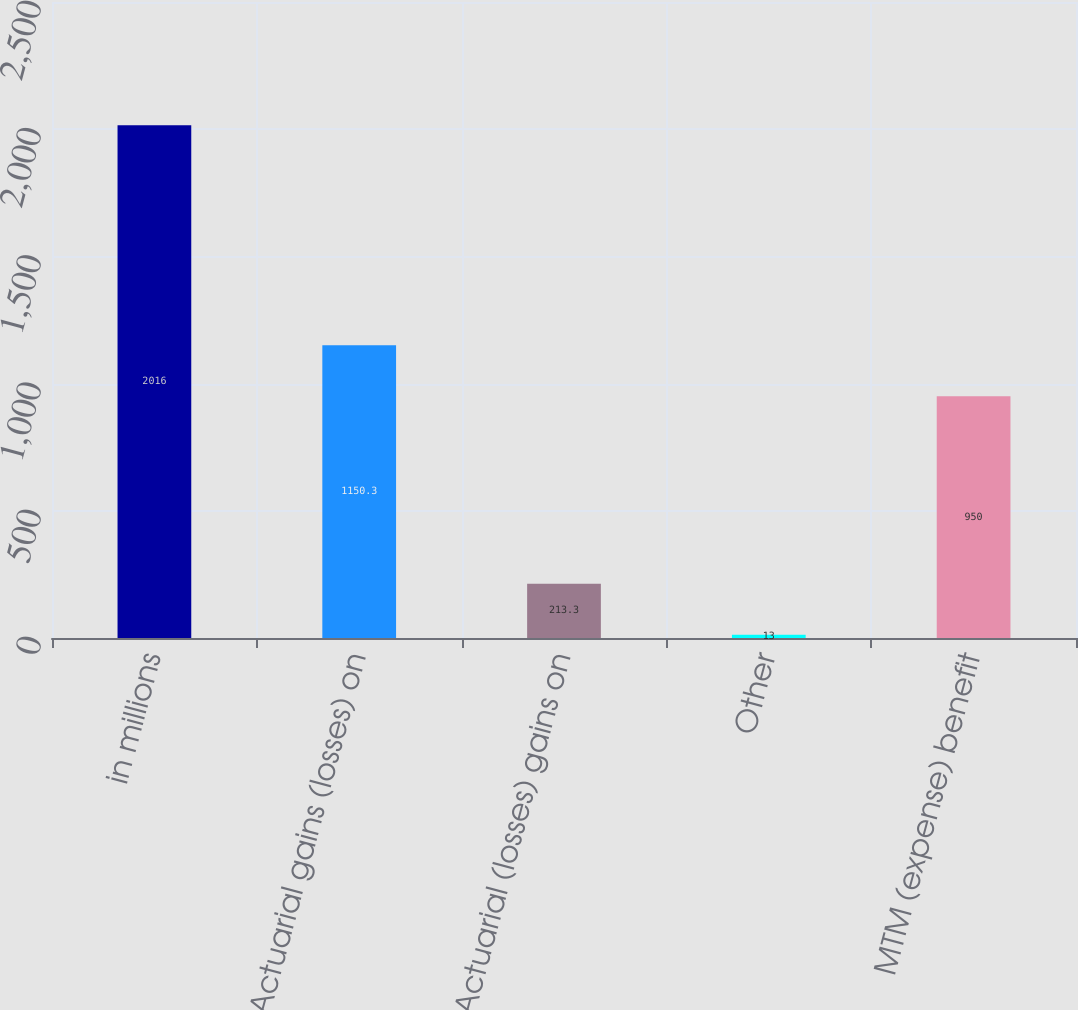Convert chart. <chart><loc_0><loc_0><loc_500><loc_500><bar_chart><fcel>in millions<fcel>Actuarial gains (losses) on<fcel>Actuarial (losses) gains on<fcel>Other<fcel>MTM (expense) benefit<nl><fcel>2016<fcel>1150.3<fcel>213.3<fcel>13<fcel>950<nl></chart> 